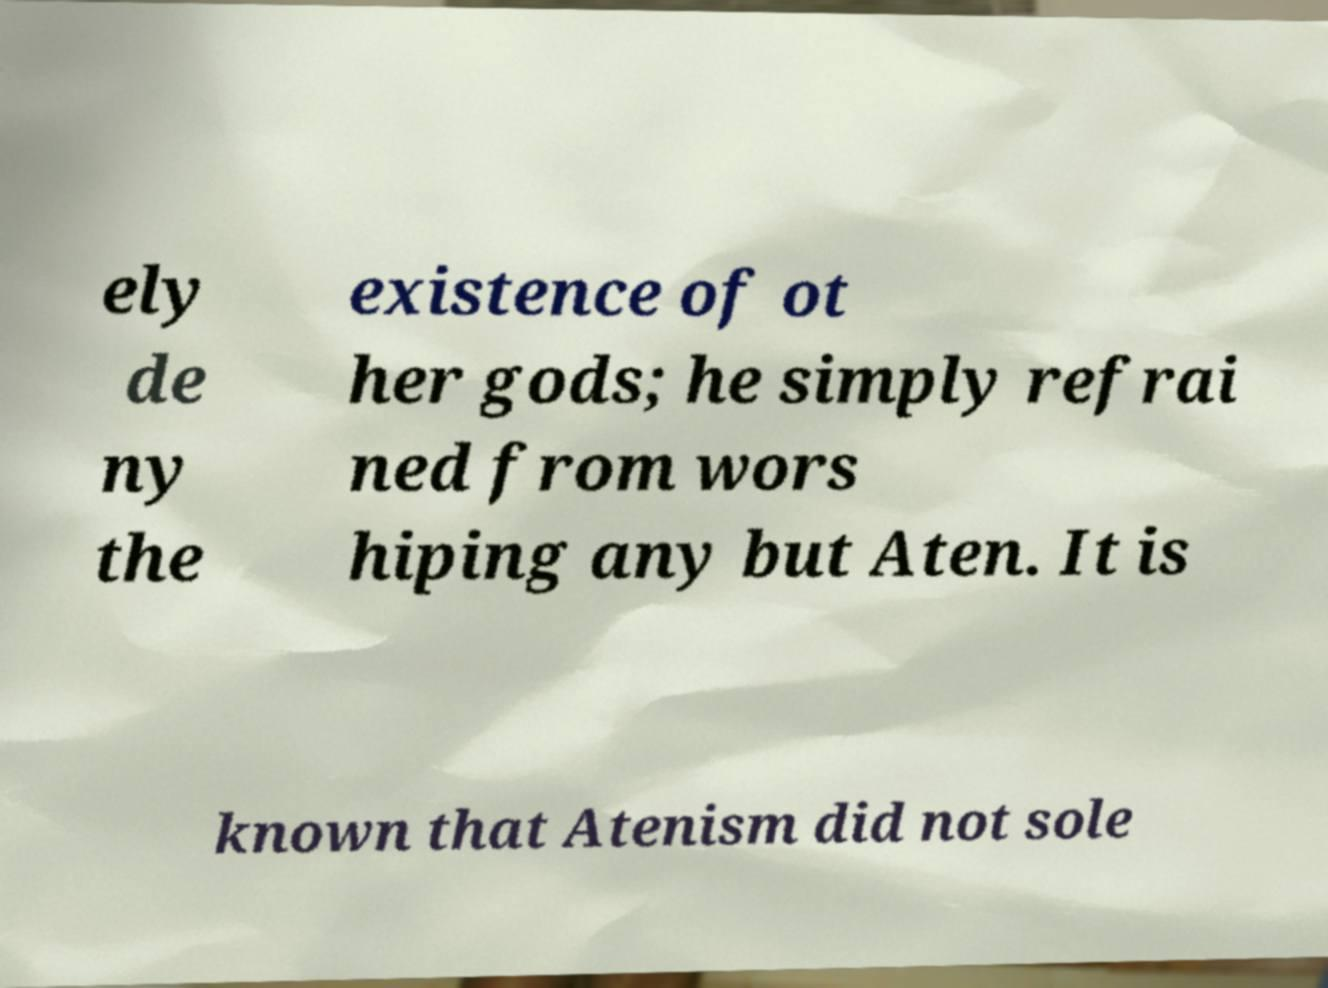Can you accurately transcribe the text from the provided image for me? ely de ny the existence of ot her gods; he simply refrai ned from wors hiping any but Aten. It is known that Atenism did not sole 